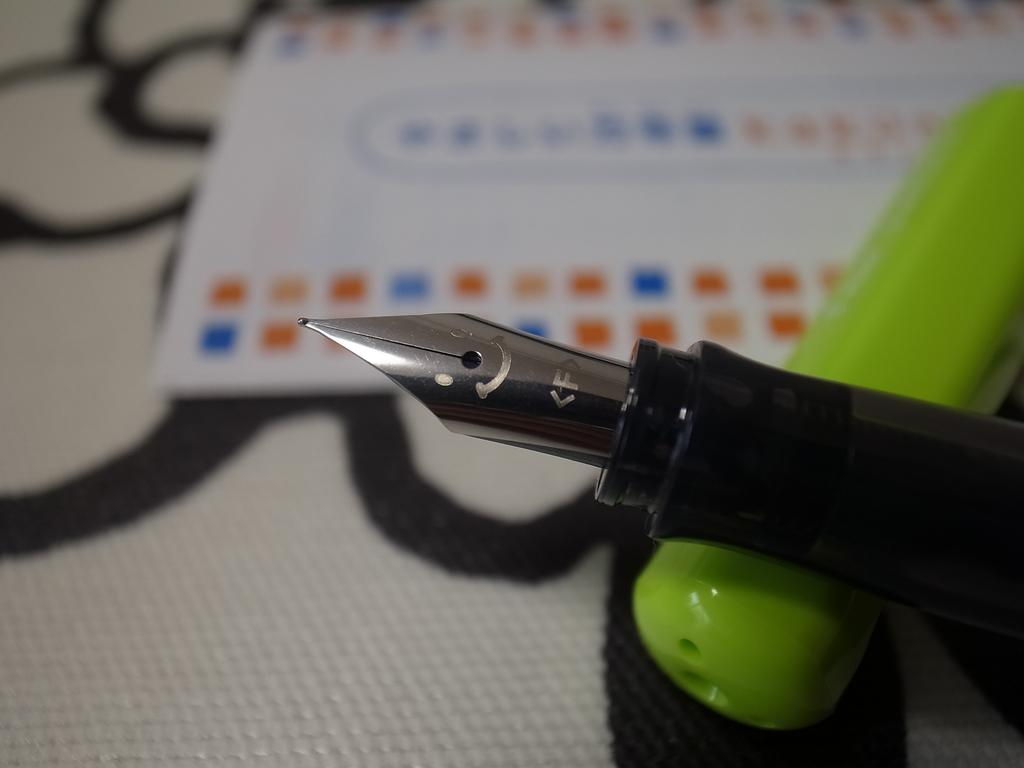What is the main object in the image? There is a pen nib in the image. What color is the object on the surface in the image? There is a green color object on the surface in the image. What is the paper in the image used for? The paper in the image is used for writing or drawing. What is the color scheme of the paper in the image? The paper is in black and white. Where is the playground located in the image? There is no playground present in the image. What type of heart can be seen in the image? There is no heart present in the image. 